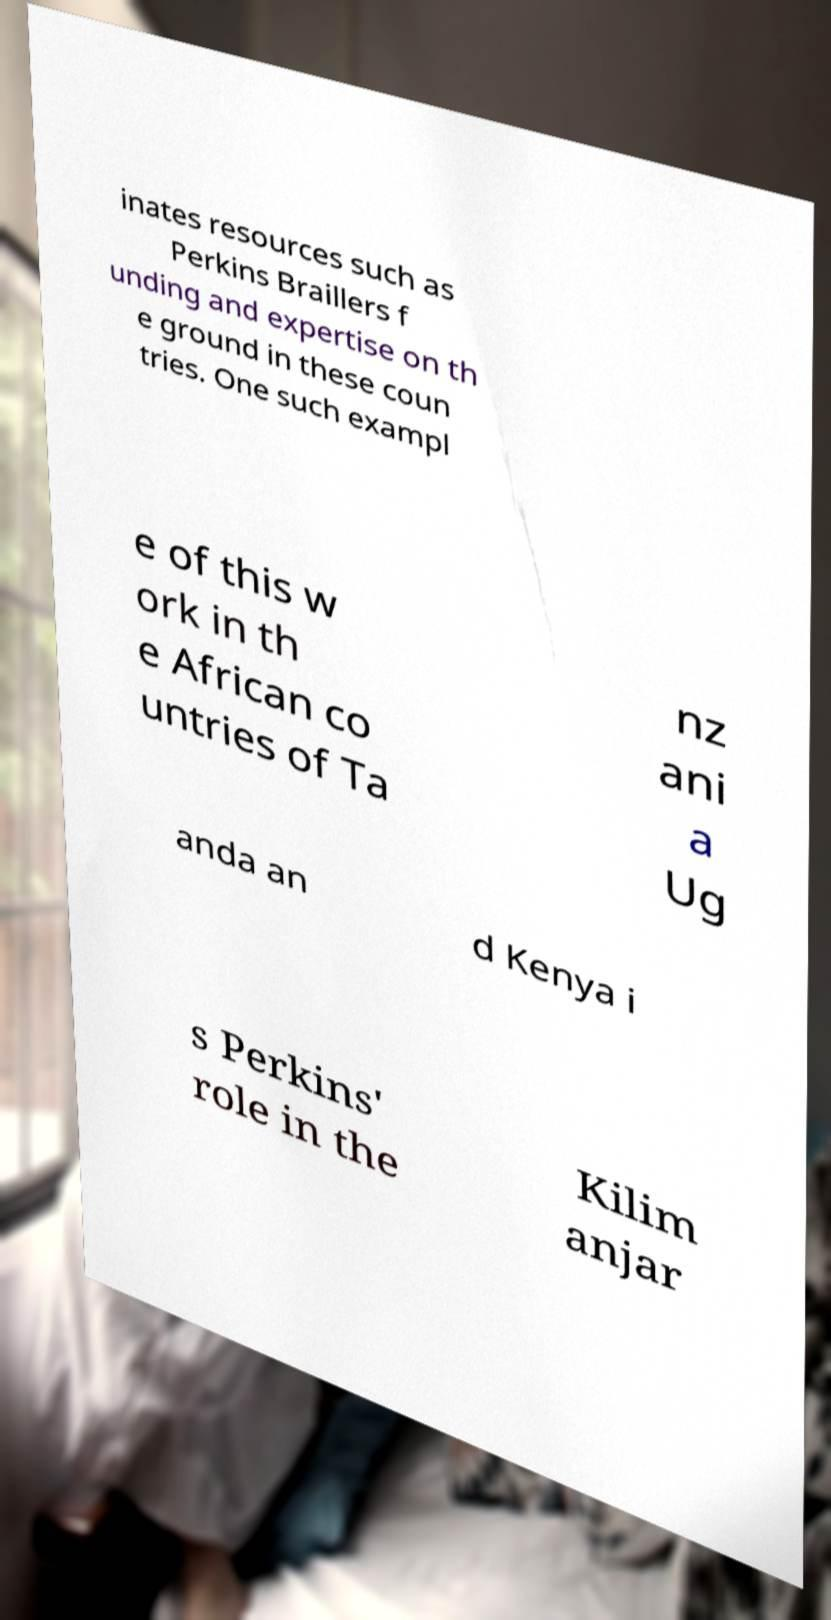I need the written content from this picture converted into text. Can you do that? inates resources such as Perkins Braillers f unding and expertise on th e ground in these coun tries. One such exampl e of this w ork in th e African co untries of Ta nz ani a Ug anda an d Kenya i s Perkins' role in the Kilim anjar 